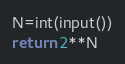Convert code to text. <code><loc_0><loc_0><loc_500><loc_500><_Python_>N=int(input())
return 2**N</code> 